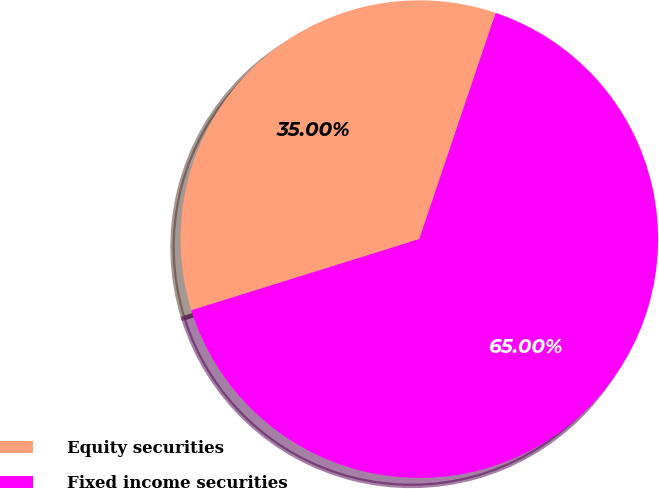Convert chart. <chart><loc_0><loc_0><loc_500><loc_500><pie_chart><fcel>Equity securities<fcel>Fixed income securities<nl><fcel>35.0%<fcel>65.0%<nl></chart> 